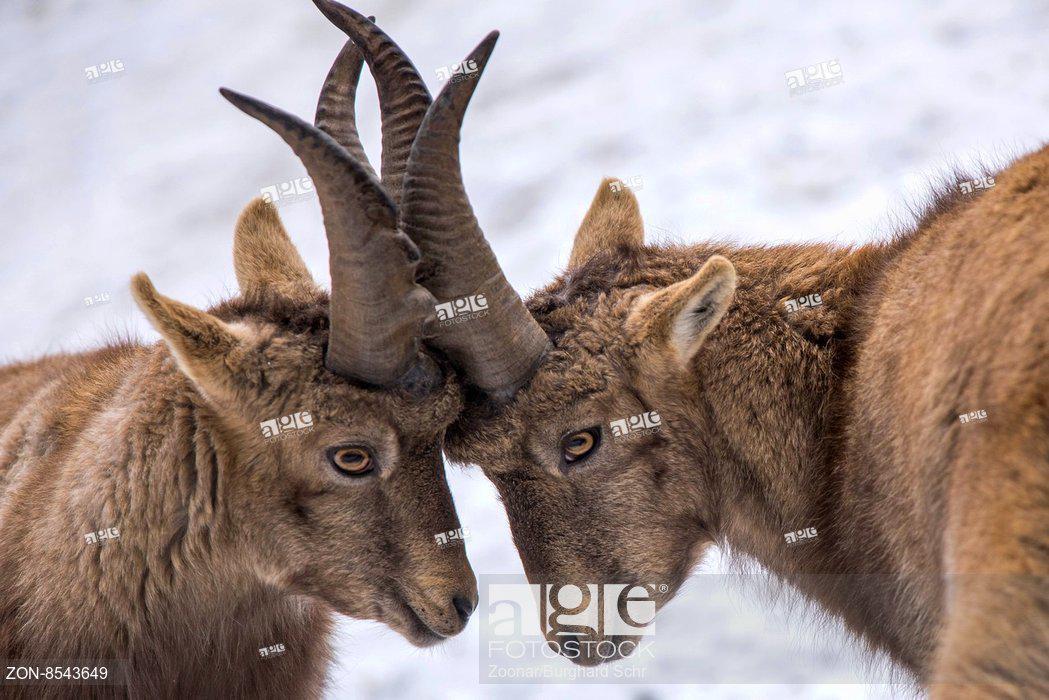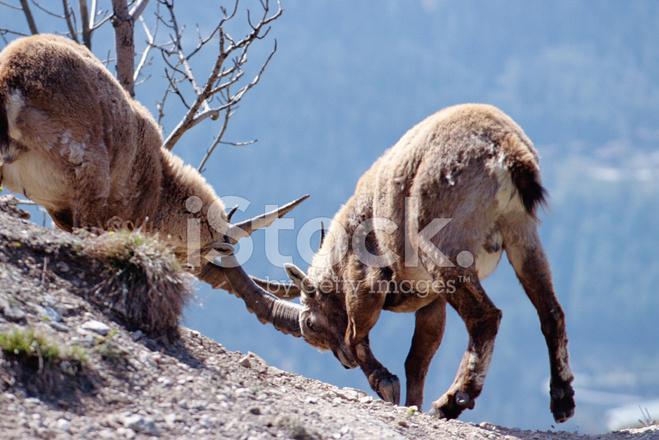The first image is the image on the left, the second image is the image on the right. Assess this claim about the two images: "The left and right image contains a total of two pairs of fight goat.". Correct or not? Answer yes or no. Yes. The first image is the image on the left, the second image is the image on the right. For the images displayed, is the sentence "There are two Ibex Rams standing on greenery." factually correct? Answer yes or no. No. 